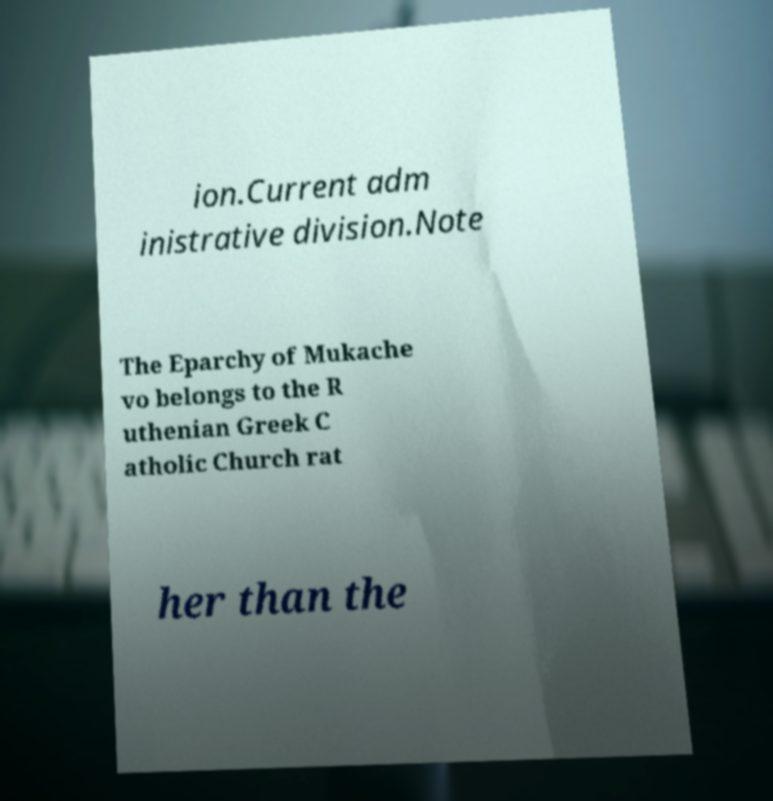Could you extract and type out the text from this image? ion.Current adm inistrative division.Note The Eparchy of Mukache vo belongs to the R uthenian Greek C atholic Church rat her than the 